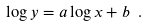<formula> <loc_0><loc_0><loc_500><loc_500>\log { y } = a \log { x } + b \ .</formula> 